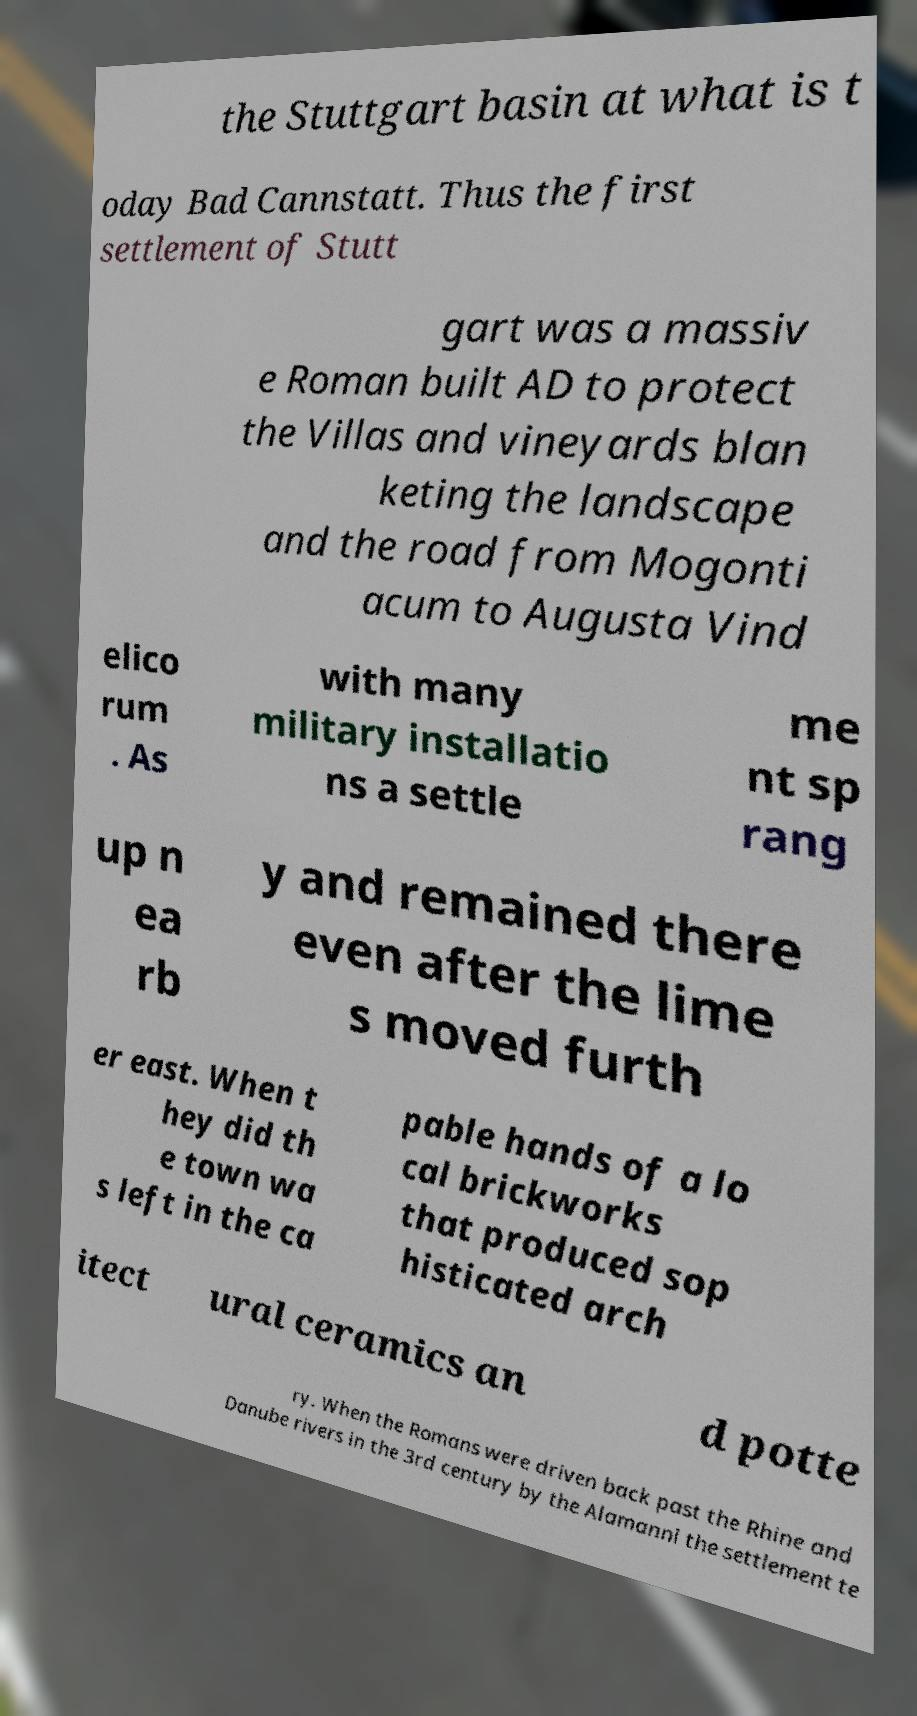I need the written content from this picture converted into text. Can you do that? the Stuttgart basin at what is t oday Bad Cannstatt. Thus the first settlement of Stutt gart was a massiv e Roman built AD to protect the Villas and vineyards blan keting the landscape and the road from Mogonti acum to Augusta Vind elico rum . As with many military installatio ns a settle me nt sp rang up n ea rb y and remained there even after the lime s moved furth er east. When t hey did th e town wa s left in the ca pable hands of a lo cal brickworks that produced sop histicated arch itect ural ceramics an d potte ry. When the Romans were driven back past the Rhine and Danube rivers in the 3rd century by the Alamanni the settlement te 